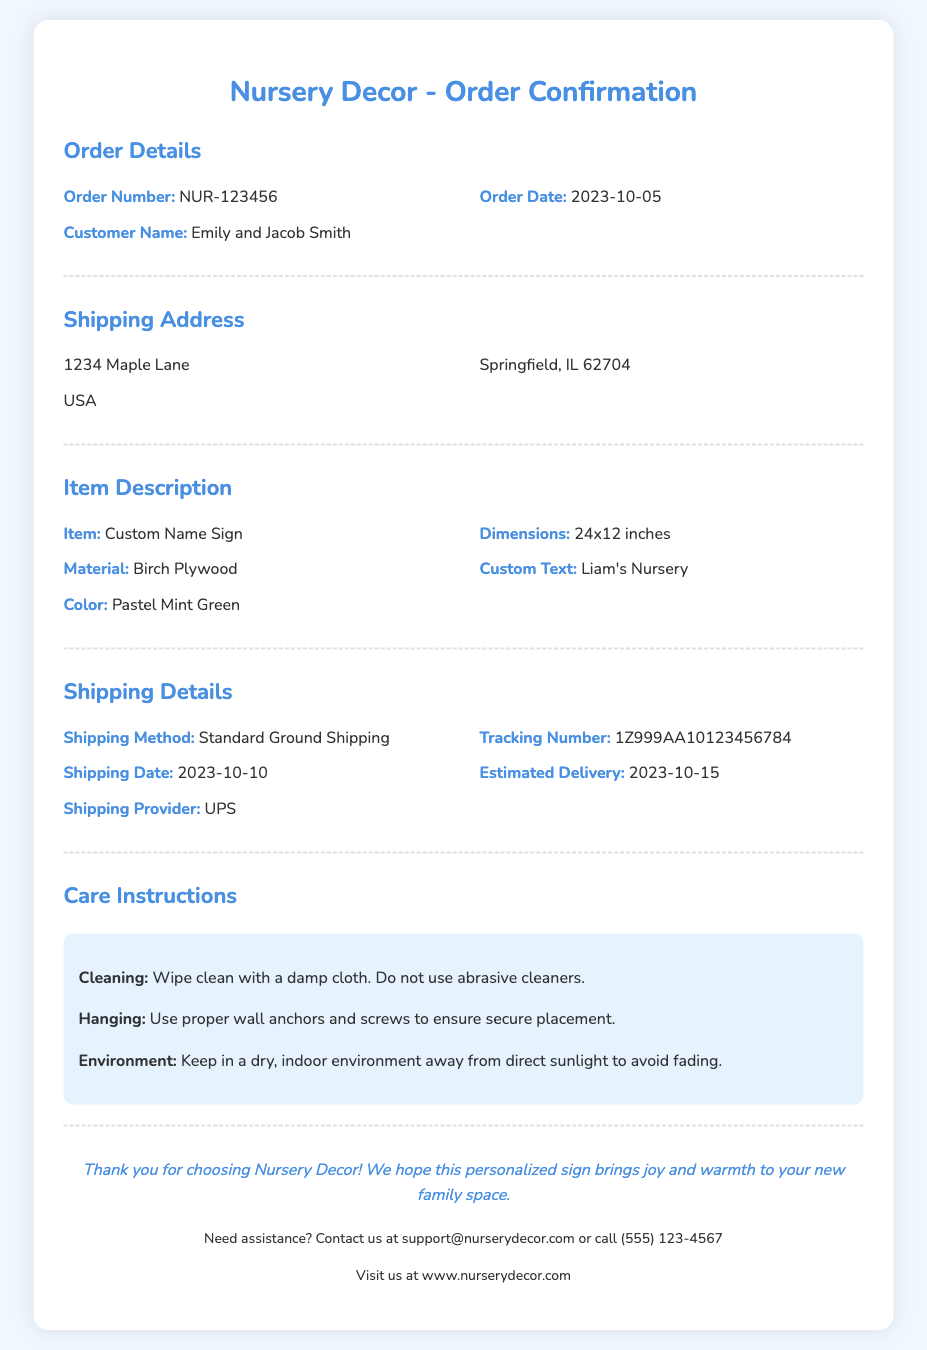What is the order number? The order number is presented in the order details section of the document.
Answer: NUR-123456 What is the customer's name? The customer's name is mentioned in the order details section.
Answer: Emily and Jacob Smith What is the shipping address? The shipping address includes the street address, city, state, and country.
Answer: 1234 Maple Lane, Springfield, IL 62704, USA What item was ordered? The item ordered is specified in the item description section.
Answer: Custom Name Sign When is the estimated delivery date? The estimated delivery date can be found in the shipping details section of the document.
Answer: 2023-10-15 What material is the item made from? The material of the item is explicitly mentioned in the item description section.
Answer: Birch Plywood What is the shipping provider? The shipping provider is listed in the shipping details section.
Answer: UPS What cleaning method is recommended? The care instructions specify the cleaning method for the item.
Answer: Wipe clean with a damp cloth What color is the custom name sign? The color of the custom name sign is detailed in the item description.
Answer: Pastel Mint Green What should you avoid using for cleaning? The care instructions caution against using certain cleaning products.
Answer: Abrasive cleaners 